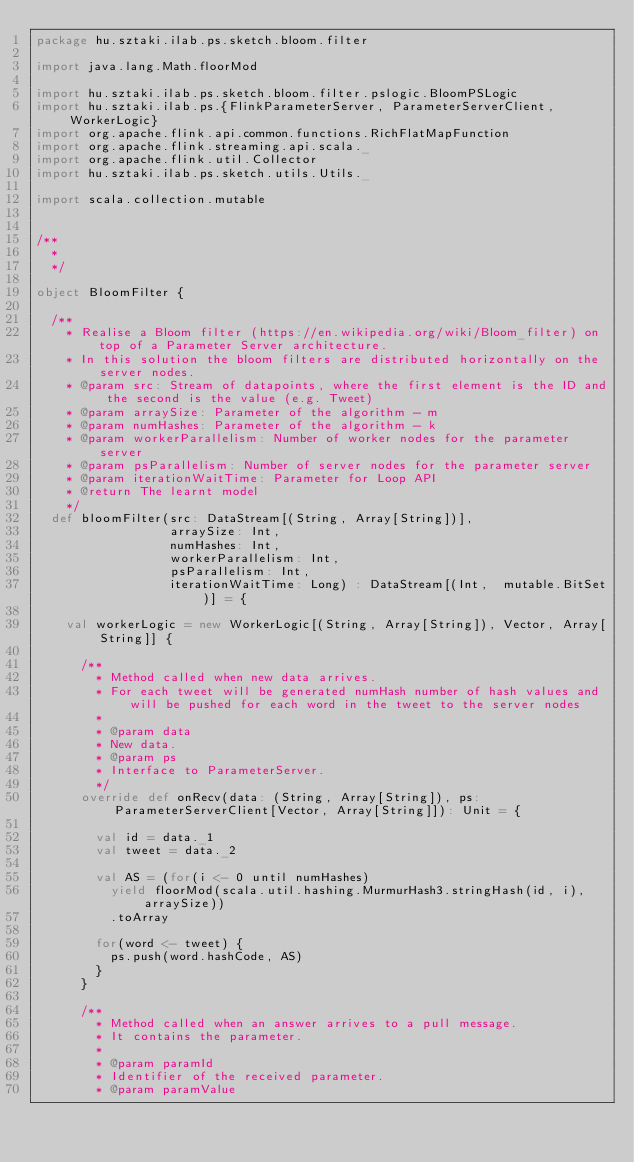Convert code to text. <code><loc_0><loc_0><loc_500><loc_500><_Scala_>package hu.sztaki.ilab.ps.sketch.bloom.filter

import java.lang.Math.floorMod

import hu.sztaki.ilab.ps.sketch.bloom.filter.pslogic.BloomPSLogic
import hu.sztaki.ilab.ps.{FlinkParameterServer, ParameterServerClient, WorkerLogic}
import org.apache.flink.api.common.functions.RichFlatMapFunction
import org.apache.flink.streaming.api.scala._
import org.apache.flink.util.Collector
import hu.sztaki.ilab.ps.sketch.utils.Utils._

import scala.collection.mutable


/**
  *
  */

object BloomFilter {

  /**
    * Realise a Bloom filter (https://en.wikipedia.org/wiki/Bloom_filter) on top of a Parameter Server architecture.
    * In this solution the bloom filters are distributed horizontally on the server nodes.
    * @param src: Stream of datapoints, where the first element is the ID and the second is the value (e.g. Tweet)
    * @param arraySize: Parameter of the algorithm - m
    * @param numHashes: Parameter of the algorithm - k
    * @param workerParallelism: Number of worker nodes for the parameter server
    * @param psParallelism: Number of server nodes for the parameter server
    * @param iterationWaitTime: Parameter for Loop API
    * @return The learnt model
    */
  def bloomFilter(src: DataStream[(String, Array[String])],
                  arraySize: Int,
                  numHashes: Int,
                  workerParallelism: Int,
                  psParallelism: Int,
                  iterationWaitTime: Long) : DataStream[(Int,  mutable.BitSet)] = {

    val workerLogic = new WorkerLogic[(String, Array[String]), Vector, Array[String]] {

      /**
        * Method called when new data arrives.
        * For each tweet will be generated numHash number of hash values and will be pushed for each word in the tweet to the server nodes
        *
        * @param data
        * New data.
        * @param ps
        * Interface to ParameterServer.
        */
      override def onRecv(data: (String, Array[String]), ps: ParameterServerClient[Vector, Array[String]]): Unit = {

        val id = data._1
        val tweet = data._2

        val AS = (for(i <- 0 until numHashes)
          yield floorMod(scala.util.hashing.MurmurHash3.stringHash(id, i), arraySize))
          .toArray

        for(word <- tweet) {
          ps.push(word.hashCode, AS)
        }
      }

      /**
        * Method called when an answer arrives to a pull message.
        * It contains the parameter.
        *
        * @param paramId
        * Identifier of the received parameter.
        * @param paramValue</code> 